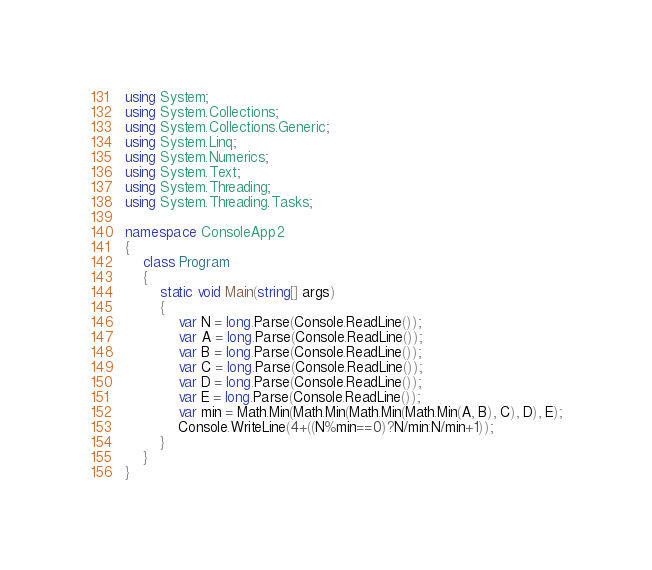<code> <loc_0><loc_0><loc_500><loc_500><_C#_>using System;
using System.Collections;
using System.Collections.Generic;
using System.Linq;
using System.Numerics;
using System.Text;
using System.Threading;
using System.Threading.Tasks;

namespace ConsoleApp2
{
    class Program
    {
        static void Main(string[] args)
        {
            var N = long.Parse(Console.ReadLine());
            var A = long.Parse(Console.ReadLine());
            var B = long.Parse(Console.ReadLine());
            var C = long.Parse(Console.ReadLine());
            var D = long.Parse(Console.ReadLine());
            var E = long.Parse(Console.ReadLine());
            var min = Math.Min(Math.Min(Math.Min(Math.Min(A, B), C), D), E);
            Console.WriteLine(4+((N%min==0)?N/min:N/min+1));
        }
    }
}</code> 